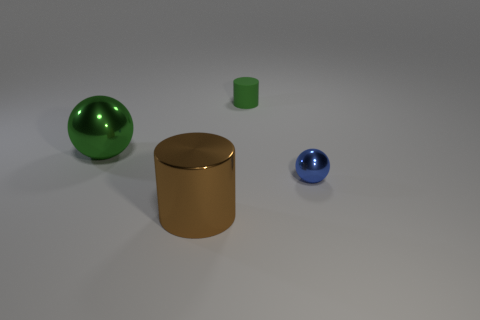Add 3 green things. How many objects exist? 7 Subtract all big brown metal objects. Subtract all big objects. How many objects are left? 1 Add 1 brown objects. How many brown objects are left? 2 Add 4 big brown shiny cylinders. How many big brown shiny cylinders exist? 5 Subtract 0 gray cylinders. How many objects are left? 4 